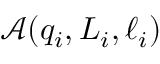Convert formula to latex. <formula><loc_0><loc_0><loc_500><loc_500>\ m a t h s c r { A } ( q _ { i } , L _ { i } , \ell _ { i } )</formula> 